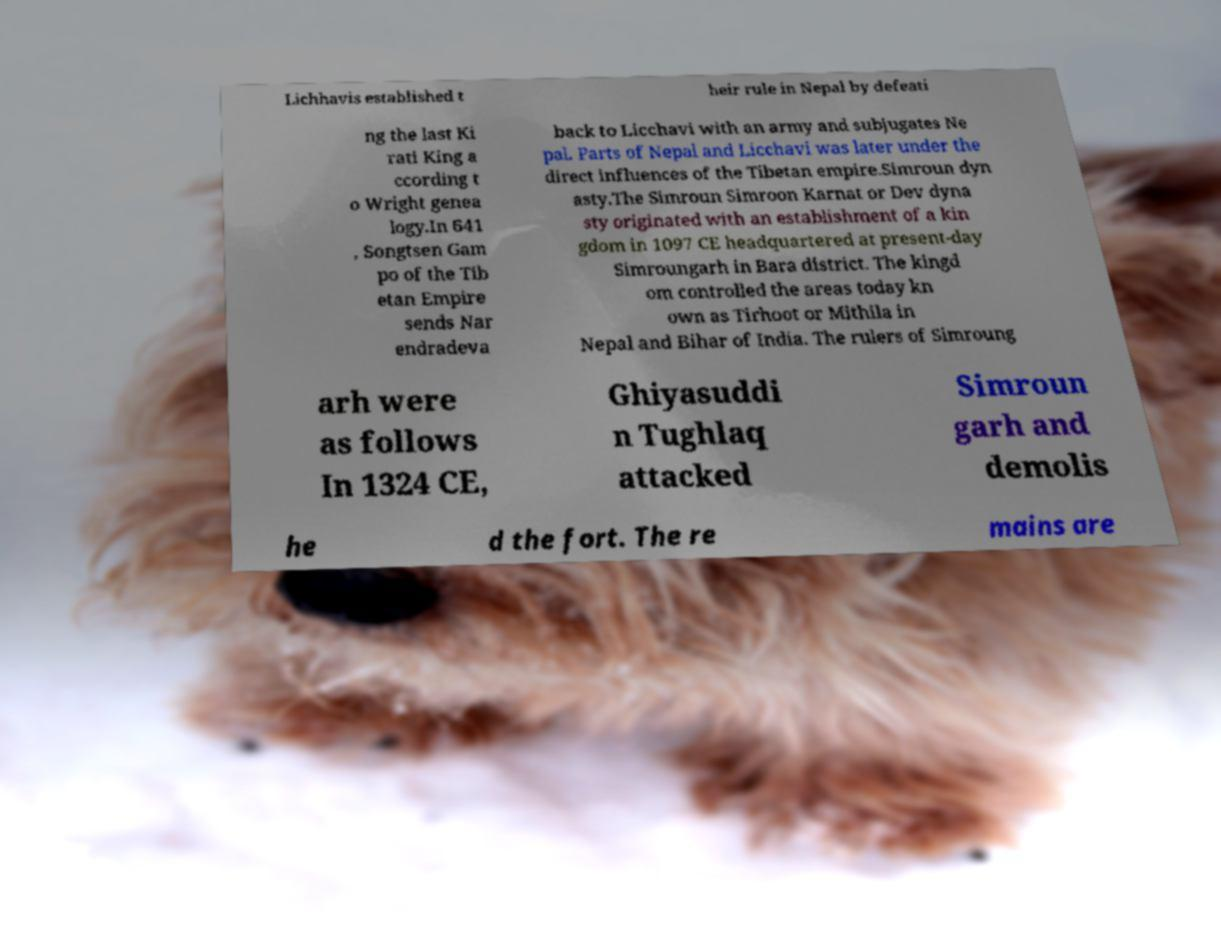Please read and relay the text visible in this image. What does it say? Lichhavis established t heir rule in Nepal by defeati ng the last Ki rati King a ccording t o Wright genea logy.In 641 , Songtsen Gam po of the Tib etan Empire sends Nar endradeva back to Licchavi with an army and subjugates Ne pal. Parts of Nepal and Licchavi was later under the direct influences of the Tibetan empire.Simroun dyn asty.The Simroun Simroon Karnat or Dev dyna sty originated with an establishment of a kin gdom in 1097 CE headquartered at present-day Simroungarh in Bara district. The kingd om controlled the areas today kn own as Tirhoot or Mithila in Nepal and Bihar of India. The rulers of Simroung arh were as follows In 1324 CE, Ghiyasuddi n Tughlaq attacked Simroun garh and demolis he d the fort. The re mains are 